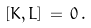Convert formula to latex. <formula><loc_0><loc_0><loc_500><loc_500>[ K , L ] \, = \, 0 \, .</formula> 